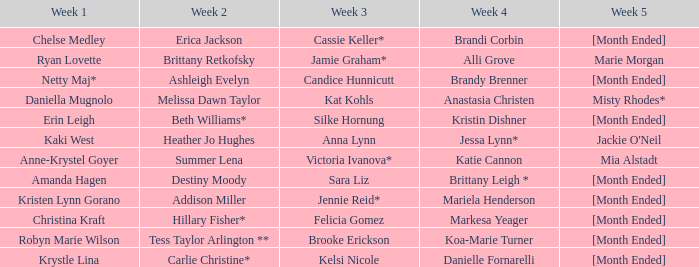What is the week 3 with addison miller in week 2? Jennie Reid*. 